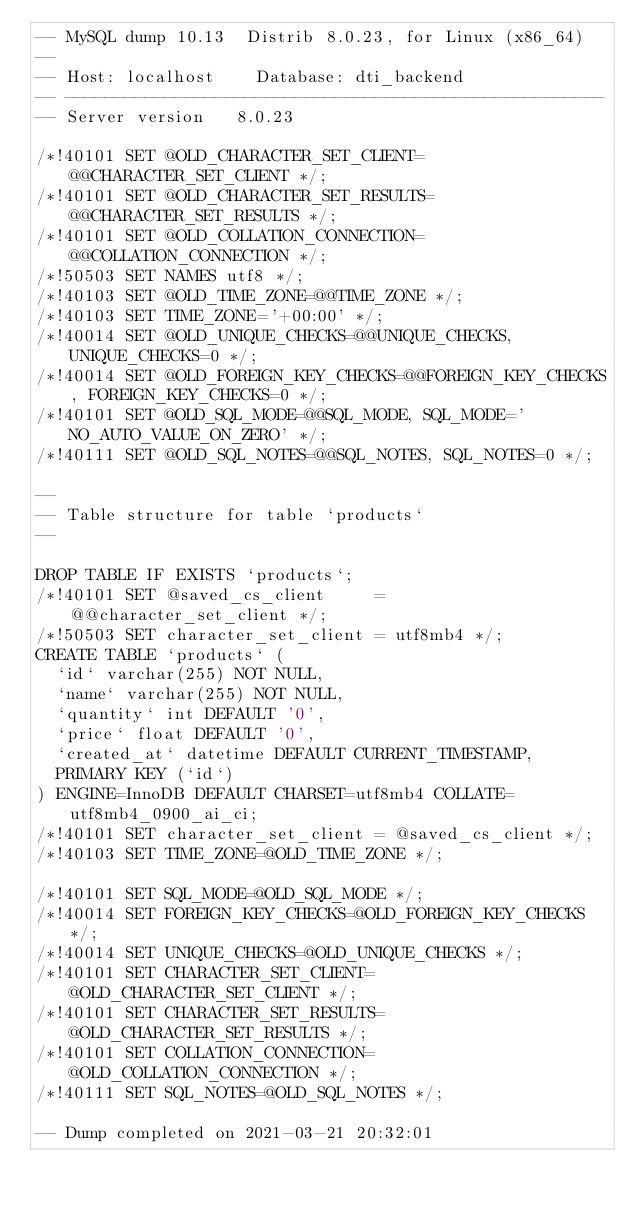Convert code to text. <code><loc_0><loc_0><loc_500><loc_500><_SQL_>-- MySQL dump 10.13  Distrib 8.0.23, for Linux (x86_64)
--
-- Host: localhost    Database: dti_backend
-- ------------------------------------------------------
-- Server version	8.0.23

/*!40101 SET @OLD_CHARACTER_SET_CLIENT=@@CHARACTER_SET_CLIENT */;
/*!40101 SET @OLD_CHARACTER_SET_RESULTS=@@CHARACTER_SET_RESULTS */;
/*!40101 SET @OLD_COLLATION_CONNECTION=@@COLLATION_CONNECTION */;
/*!50503 SET NAMES utf8 */;
/*!40103 SET @OLD_TIME_ZONE=@@TIME_ZONE */;
/*!40103 SET TIME_ZONE='+00:00' */;
/*!40014 SET @OLD_UNIQUE_CHECKS=@@UNIQUE_CHECKS, UNIQUE_CHECKS=0 */;
/*!40014 SET @OLD_FOREIGN_KEY_CHECKS=@@FOREIGN_KEY_CHECKS, FOREIGN_KEY_CHECKS=0 */;
/*!40101 SET @OLD_SQL_MODE=@@SQL_MODE, SQL_MODE='NO_AUTO_VALUE_ON_ZERO' */;
/*!40111 SET @OLD_SQL_NOTES=@@SQL_NOTES, SQL_NOTES=0 */;

--
-- Table structure for table `products`
--

DROP TABLE IF EXISTS `products`;
/*!40101 SET @saved_cs_client     = @@character_set_client */;
/*!50503 SET character_set_client = utf8mb4 */;
CREATE TABLE `products` (
  `id` varchar(255) NOT NULL,
  `name` varchar(255) NOT NULL,
  `quantity` int DEFAULT '0',
  `price` float DEFAULT '0',
  `created_at` datetime DEFAULT CURRENT_TIMESTAMP,
  PRIMARY KEY (`id`)
) ENGINE=InnoDB DEFAULT CHARSET=utf8mb4 COLLATE=utf8mb4_0900_ai_ci;
/*!40101 SET character_set_client = @saved_cs_client */;
/*!40103 SET TIME_ZONE=@OLD_TIME_ZONE */;

/*!40101 SET SQL_MODE=@OLD_SQL_MODE */;
/*!40014 SET FOREIGN_KEY_CHECKS=@OLD_FOREIGN_KEY_CHECKS */;
/*!40014 SET UNIQUE_CHECKS=@OLD_UNIQUE_CHECKS */;
/*!40101 SET CHARACTER_SET_CLIENT=@OLD_CHARACTER_SET_CLIENT */;
/*!40101 SET CHARACTER_SET_RESULTS=@OLD_CHARACTER_SET_RESULTS */;
/*!40101 SET COLLATION_CONNECTION=@OLD_COLLATION_CONNECTION */;
/*!40111 SET SQL_NOTES=@OLD_SQL_NOTES */;

-- Dump completed on 2021-03-21 20:32:01
</code> 